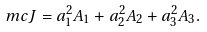Convert formula to latex. <formula><loc_0><loc_0><loc_500><loc_500>\ m c J = a _ { 1 } ^ { 2 } A _ { 1 } + a _ { 2 } ^ { 2 } A _ { 2 } + a _ { 3 } ^ { 2 } A _ { 3 } .</formula> 